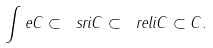Convert formula to latex. <formula><loc_0><loc_0><loc_500><loc_500>\int e C \subset \ s r i C \subset \ r e l i C \subset C .</formula> 